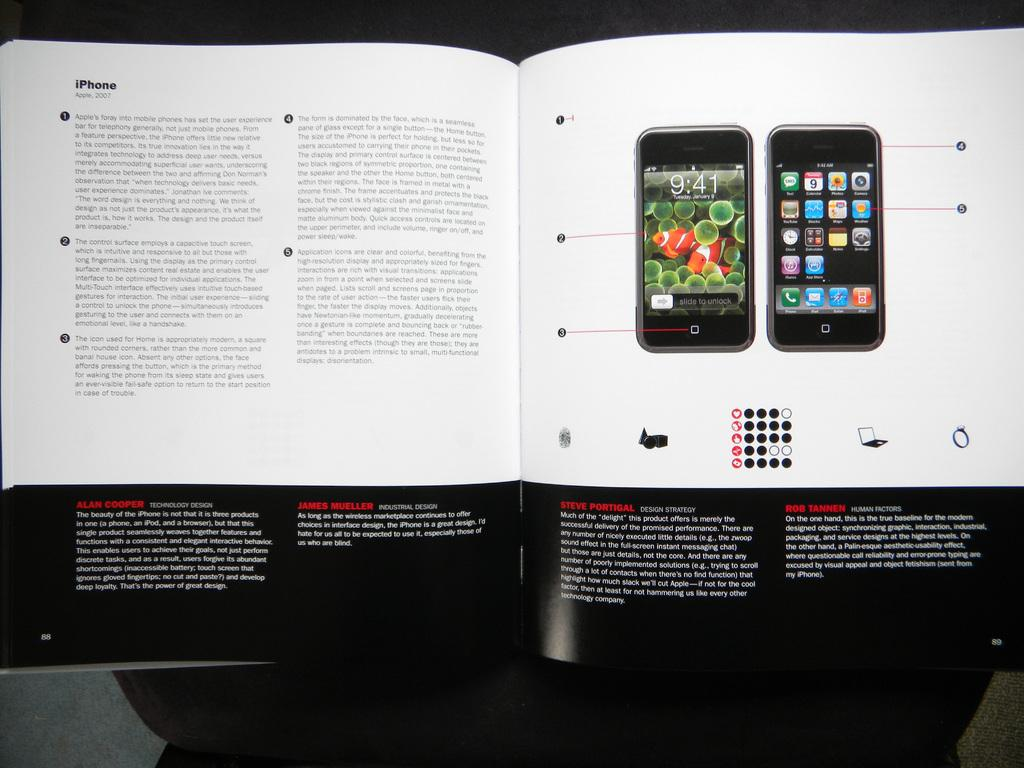<image>
Present a compact description of the photo's key features. An iPhone ad is dated 2007 and shows pictures of phones. 